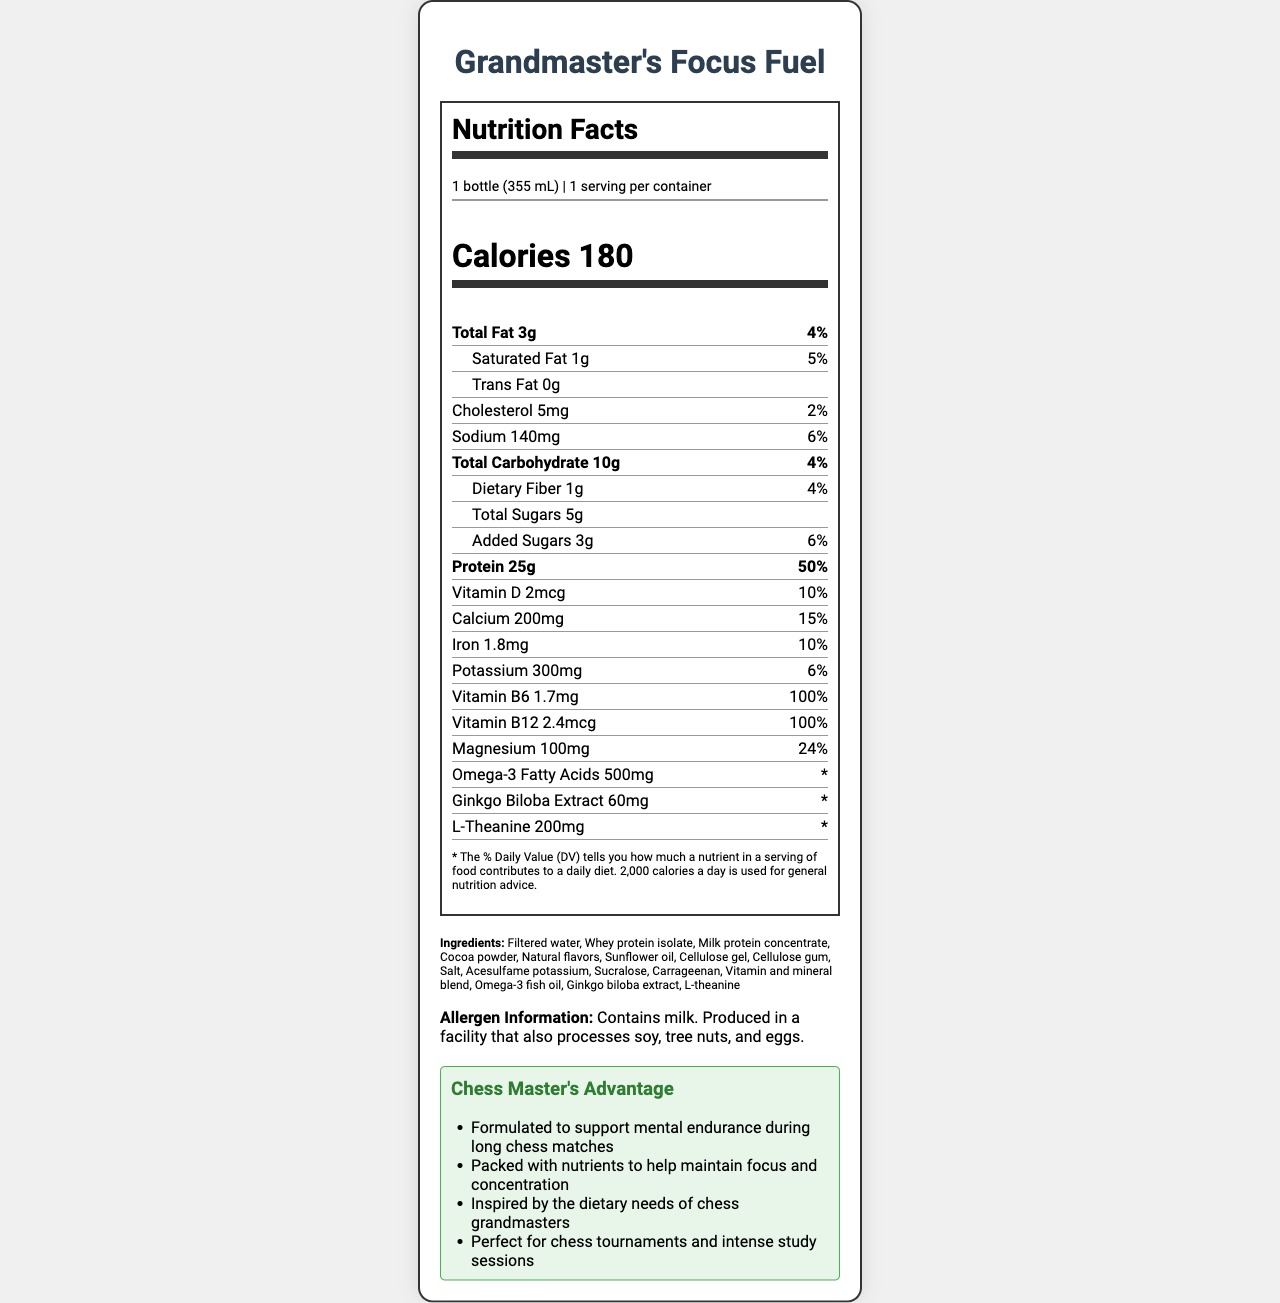how many calories are in a serving of Grandmaster's Focus Fuel? The document states that there are 180 calories per serving.
Answer: 180 what is the serving size for Grandmaster's Focus Fuel? According to the document, the serving size is 1 bottle (355 mL).
Answer: 1 bottle (355 mL) how much protein does one serving contain? The document specifies that one serving contains 25 grams of protein, which amounts to 50% of the daily value.
Answer: 25g how much total fat is in one serving, and what percentage of the daily value does it represent? The document indicates that one serving contains 3 grams of total fat, which is 4% of the daily value.
Answer: 3g, 4% what allergens are present in Grandmaster's Focus Fuel? The allergen information section of the document states that the product contains milk and is produced in a facility that processes soy, tree nuts, and eggs.
Answer: Milk how much sodium does one serving of Grandmaster's Focus Fuel contain? A. 100mg B. 120mg C. 140mg D. 160mg The document indicates that one serving contains 140mg of sodium, which is 6% of the daily value.
Answer: C. 140mg what is the daily value percentage of calcium in a serving of Grandmaster's Focus Fuel? A. 10% B. 15% C. 20% D. 25% According to the document, one serving provides 200mg of calcium, which is 15% of the daily value.
Answer: B. 15% does Grandmaster's Focus Fuel contain any added sugars? The document indicates that it contains 3g of added sugars, which is 6% of the daily value.
Answer: Yes is the omega-3 fatty acids percentage of daily value provided? The document lists the amount of omega-3 fatty acids as 500mg but does not provide the daily value percentage.
Answer: No summarize the purpose of Grandmaster's Focus Fuel as stated in the document. The document describes the product's purpose as supporting mental endurance and focus during chess matches, providing essential nutrients to maintain concentration, and being ideal for tournaments and intense study sessions.
Answer: Grandmaster's Focus Fuel is a chess-themed protein shake designed to support mental focus and endurance during chess matches. It is packed with nutrients, including essential vitamins, minerals, and proteins, aimed at maintaining concentration and enhancing mental performance, inspired by the dietary needs of chess grandmasters. how many servings are in one container of Grandmaster's Focus Fuel? The document specifies that there is 1 serving per container.
Answer: 1 what are the primary protein sources in Grandmaster's Focus Fuel? The ingredients section of the document lists whey protein isolate and milk protein concentrate as the primary protein sources.
Answer: Whey protein isolate and milk protein concentrate what are the additional mental focus ingredients in Grandmaster's Focus Fuel? The document lists Ginkgo biloba extract (60mg) and L-theanine (200mg) as ingredients formulated to enhance mental focus.
Answer: Ginkgo biloba extract and L-theanine can the document provide information about the environmental impact of the ingredients? The document does not provide any information regarding the environmental impact of the ingredients used in Grandmaster's Focus Fuel.
Answer: Cannot be determined what inspired the formulation of Grandmaster's Focus Fuel? The marketing claims section states that the product is inspired by the dietary needs of chess grandmasters.
Answer: Dietary needs of chess grandmasters 